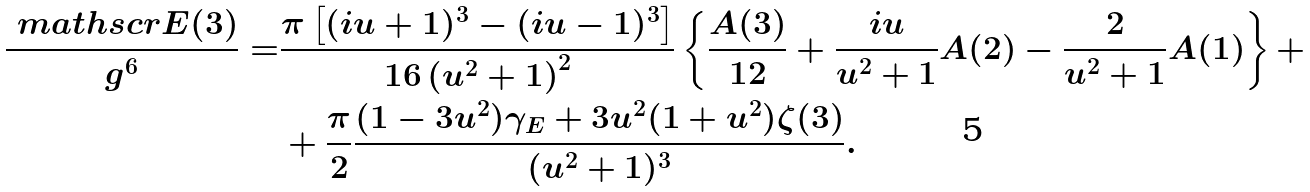Convert formula to latex. <formula><loc_0><loc_0><loc_500><loc_500>\frac { \ m a t h s c r { E } ( 3 ) } { g ^ { 6 } } = & \frac { \pi \left [ ( i u + 1 ) ^ { 3 } - ( i u - 1 ) ^ { 3 } \right ] } { 1 6 \left ( u ^ { 2 } + 1 \right ) ^ { 2 } } \left \{ \frac { A ( 3 ) } { 1 2 } + \frac { i u } { u ^ { 2 } + 1 } A ( 2 ) - \frac { 2 } { u ^ { 2 } + 1 } A ( 1 ) \right \} + \\ & + \frac { \pi } { 2 } \frac { ( 1 - 3 u ^ { 2 } ) \gamma _ { E } + 3 u ^ { 2 } ( 1 + u ^ { 2 } ) \zeta ( 3 ) } { ( u ^ { 2 } + 1 ) ^ { 3 } } .</formula> 